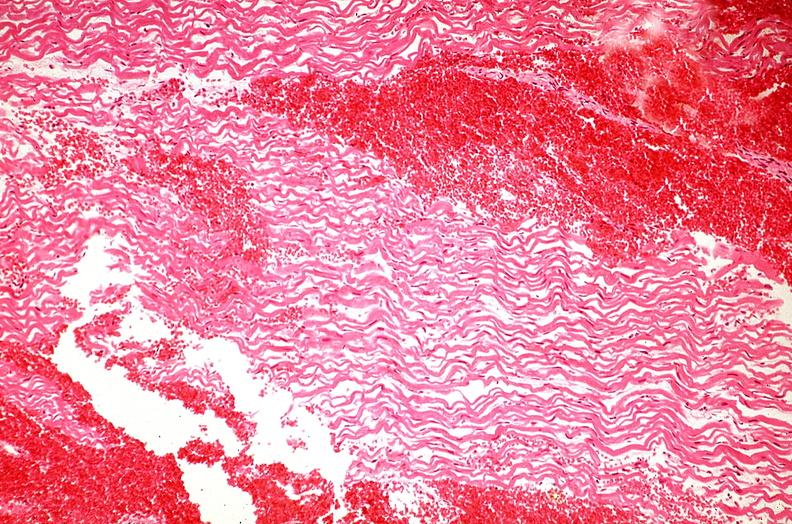where is this from?
Answer the question using a single word or phrase. Heart 